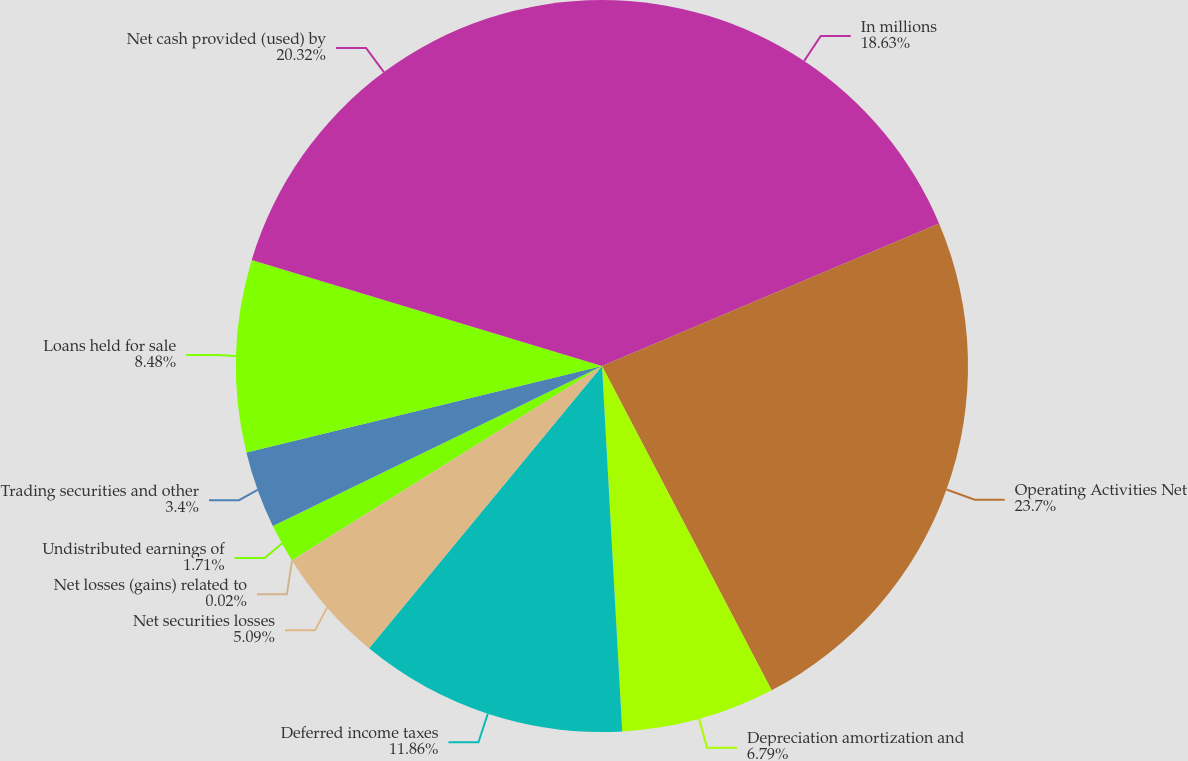<chart> <loc_0><loc_0><loc_500><loc_500><pie_chart><fcel>In millions<fcel>Operating Activities Net<fcel>Depreciation amortization and<fcel>Deferred income taxes<fcel>Net securities losses<fcel>Net losses (gains) related to<fcel>Undistributed earnings of<fcel>Trading securities and other<fcel>Loans held for sale<fcel>Net cash provided (used) by<nl><fcel>18.63%<fcel>23.7%<fcel>6.79%<fcel>11.86%<fcel>5.09%<fcel>0.02%<fcel>1.71%<fcel>3.4%<fcel>8.48%<fcel>20.32%<nl></chart> 